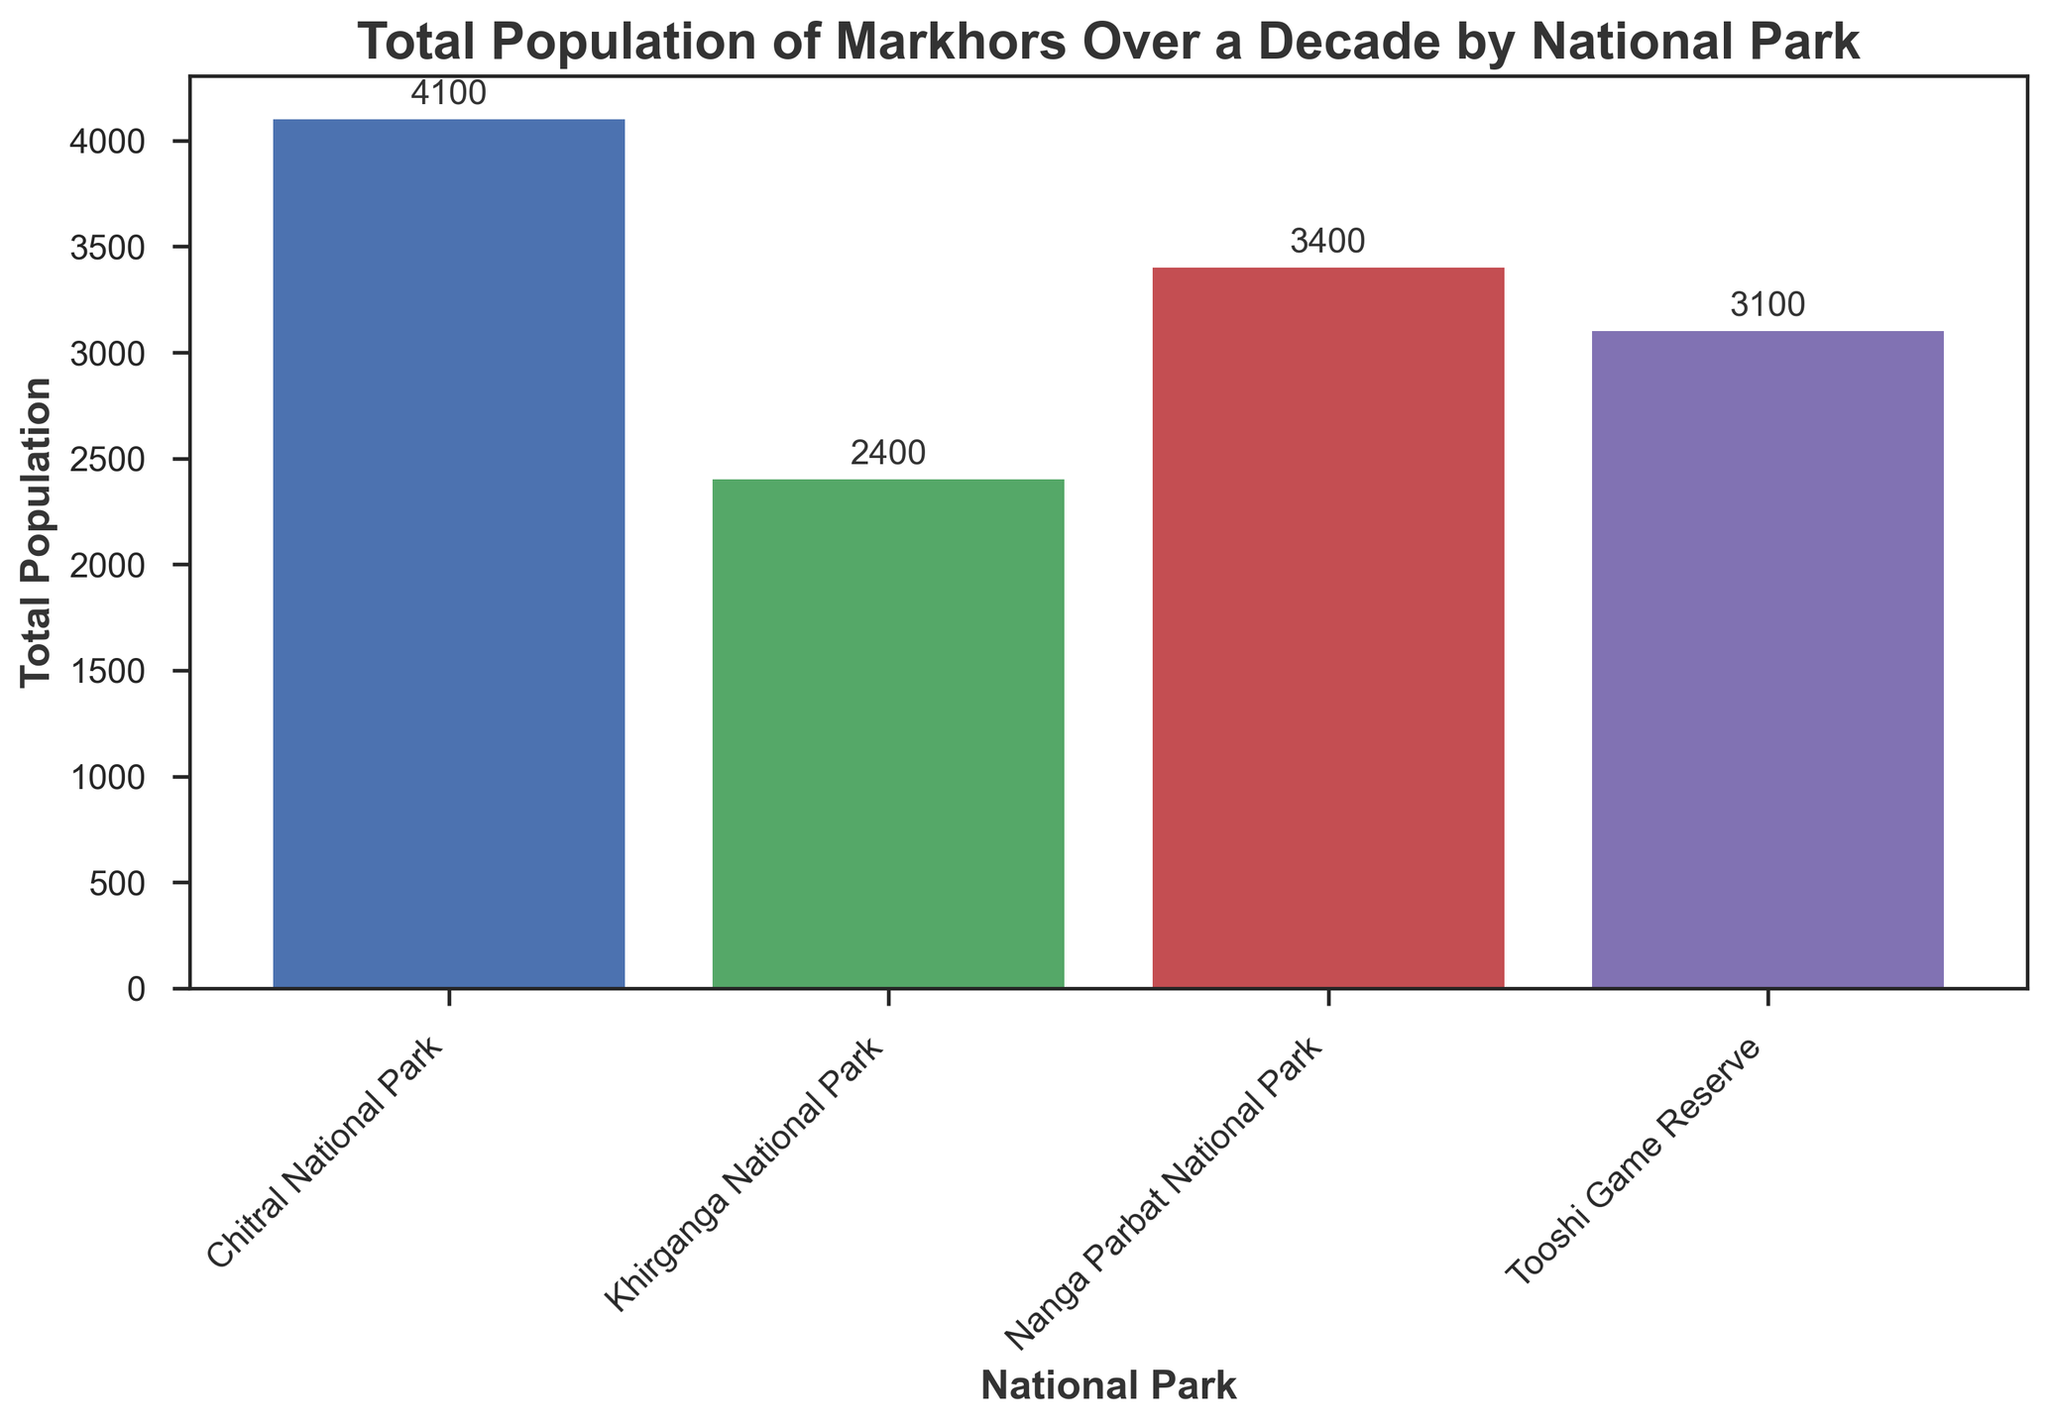Which national park has the highest Markhor population over the decade? To find the highest population, look at the heights of the bars. The bar for Chitral National Park is the tallest, indicating it has the highest population.
Answer: Chitral National Park What is the difference in total Markhor population between Nanga Parbat National Park and Khirganga National Park over the decade? Find the total population for each park by looking at the heights of the bars. Nanga Parbat National Park has about 3400, and Khirganga National Park has about 2200. The difference is 3400 - 2200.
Answer: 1200 Which national park has the lowest Markhor population over the decade, and what is its population? Look for the shortest bar, which is for Khirganga National Park. The annotated value on the bar indicates the population.
Answer: Khirganga National Park, 2200 How much more populated is Chitral National Park compared to Tooshi Game Reserve over the decade? Find the population for each park by looking at the heights of the bars. Chitral National Park has about 4000, and Tooshi Game Reserve has about 3160. Subtract the smaller one from the larger one.
Answer: 840 What is the total population of Markhors in all the parks combined over the decade? Sum the populations from all the bars. 3400 (Nanga Parbat) + 4000 (Chitral) + 2200 (Khirganga) + 3160 (Tooshi) = 12760.
Answer: 12760 If the population of Nanga Parbat National Park grew linearly over the decade, what was the average annual population increase? The total population increase over the decade is the difference between the population in 2022 and 2013, which is 430 - 250 = 180. Over 9 years, the average annual increase is 180 / 9.
Answer: 20 Which two parks have the smallest difference in their total Markhor populations over the decade? Compare the population heights to find the smallest difference. Nanga Parbat National Park (3400) and Tooshi Game Reserve (3160) have the smallest difference.
Answer: Nanga Parbat National Park and Tooshi Game Reserve What color is used to represent the bar for Chitral National Park? Look at the color of the bar corresponding to Chitral National Park.
Answer: Green What is the sum of the populations of the two national parks with the highest populations over the decade? Identify the two parks with the highest bars, which are Chitral National Park and Nanga Parbat National Park. Sum their populations: 4000 (Chitral) + 3400 (Nanga Parbat) = 7400.
Answer: 7400 What is the average total population of Markhors across all the parks over the decade? The combined total population across all parks is 12760, and there are 4 parks. The average is 12760 / 4.
Answer: 3190 